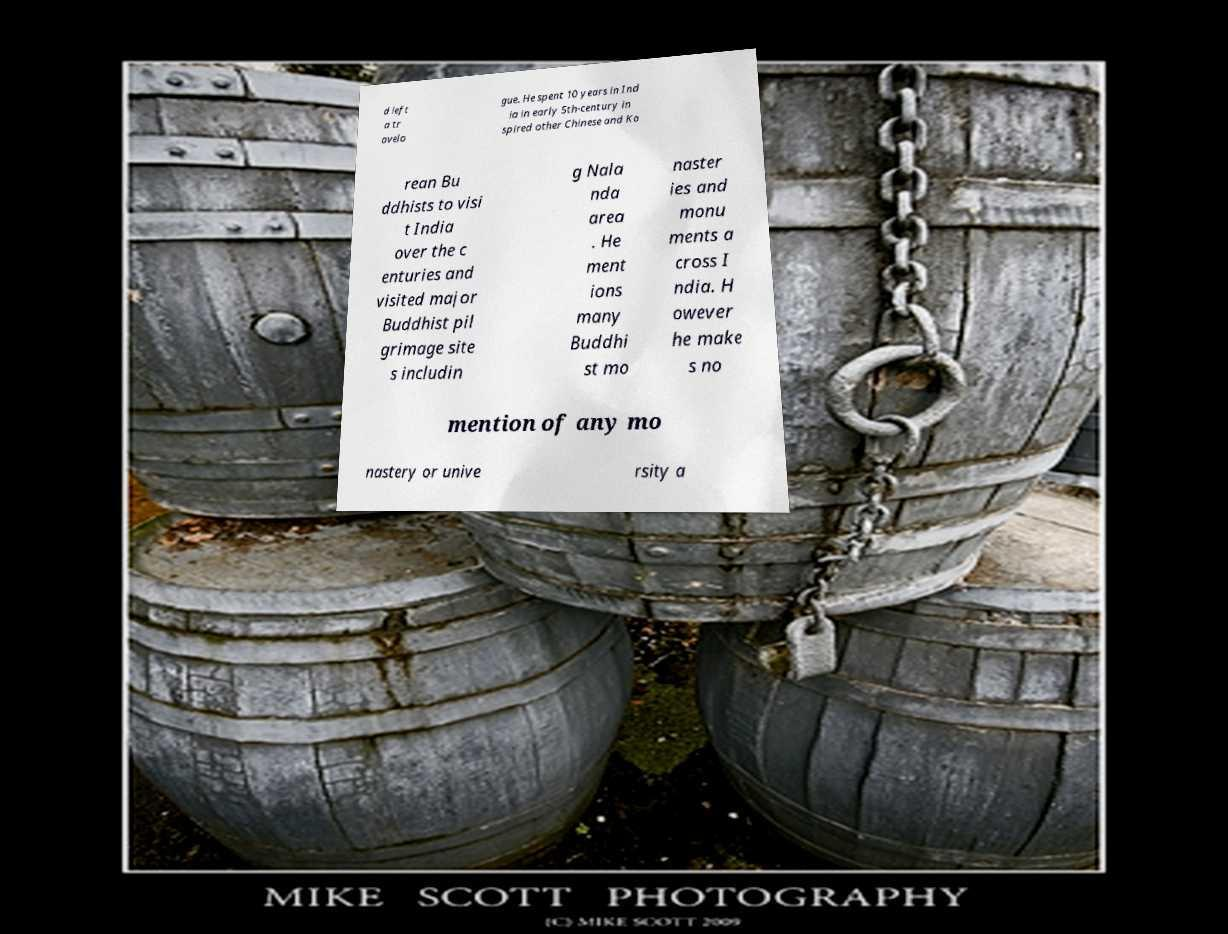Can you read and provide the text displayed in the image?This photo seems to have some interesting text. Can you extract and type it out for me? d left a tr avelo gue. He spent 10 years in Ind ia in early 5th-century in spired other Chinese and Ko rean Bu ddhists to visi t India over the c enturies and visited major Buddhist pil grimage site s includin g Nala nda area . He ment ions many Buddhi st mo naster ies and monu ments a cross I ndia. H owever he make s no mention of any mo nastery or unive rsity a 